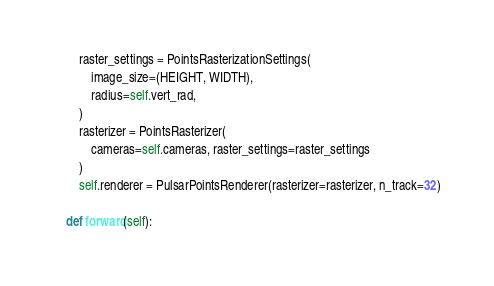<code> <loc_0><loc_0><loc_500><loc_500><_Python_>        raster_settings = PointsRasterizationSettings(
            image_size=(HEIGHT, WIDTH),
            radius=self.vert_rad,
        )
        rasterizer = PointsRasterizer(
            cameras=self.cameras, raster_settings=raster_settings
        )
        self.renderer = PulsarPointsRenderer(rasterizer=rasterizer, n_track=32)

    def forward(self):</code> 